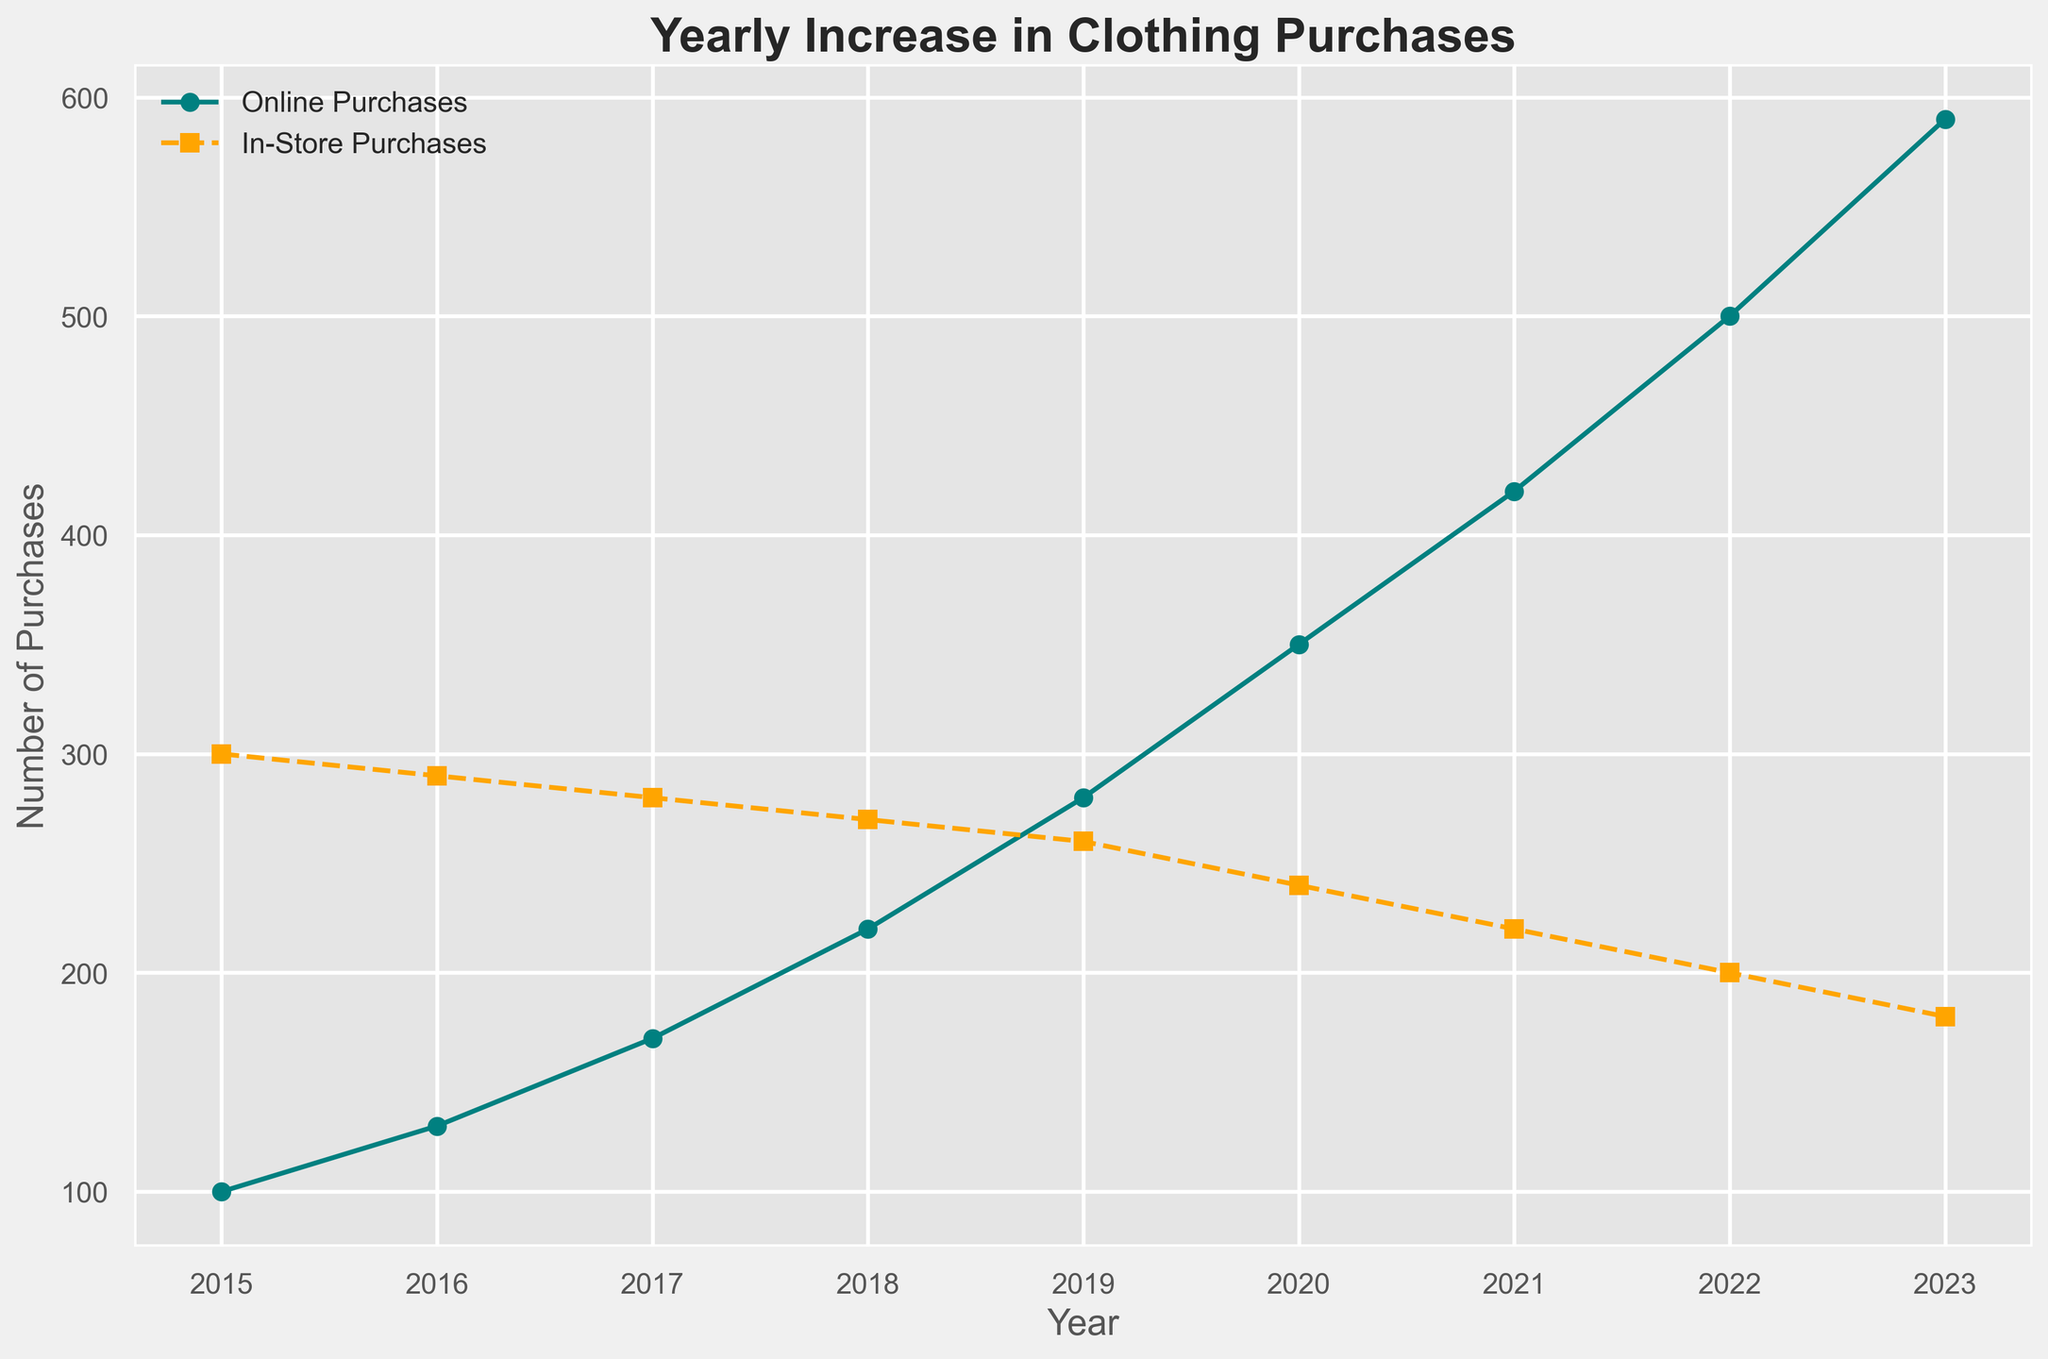What is the trend in online clothing purchases from 2015 to 2023? To determine the trend in online clothing purchases, observe the online purchases line in the chart, which shows a rising pattern year over year.
Answer: Increasing How many more online purchases were there in 2023 compared to 2015? Subtract the number of online purchases in 2015 from that in 2023: 590 - 100 = 490
Answer: 490 What is the largest difference in purchases between online and in-store in any given year? Check the vertical distance between the lines for each year. The largest difference is in 2023, with online purchases at 590 and in-store purchases at 180. Calculate the difference: 590 - 180 = 410
Answer: 410 Which year showed the smallest difference between online and in-store purchases? Look at the vertical distance between the lines for each year. The smallest difference is in 2015 where online purchases are 100 and in-store are 300. Calculate the difference: 300 - 100 = 200
Answer: 2015 In which year did online purchases surpass in-store purchases? Look at the lines to see where the online purchases line crosses above the in-store purchases line. This occurs between 2018 (220 online, 270 in-store) and 2019 (280 online, 260 in-store).
Answer: 2019 How much did in-store purchases decrease from 2015 to 2023? Subtract the number of in-store purchases in 2023 from that in 2015: 300 - 180 = 120
Answer: 120 What is the average number of online purchases from 2015 to 2023? Sum the online purchases from each year and divide by the number of years: (100 + 130 + 170 + 220 + 280 + 350 + 420 + 500 + 590) / 9 = 306.67
Answer: 306.67 Identify the year with the highest number of online purchases. Find the year with the peak of the online purchases curve, which is 2023 at 590 purchases.
Answer: 2023 Compare the trend slopes of online and in-store purchases. Which one is steeper and what does this indicate? The slope of the online purchases line is steeper than the in-store purchases line, indicating a faster increase in online purchases compared to the drop in in-store purchases over the years.
Answer: Online purchases slope is steeper From 2018 to 2022, what is the average yearly increase in online purchases? Calculate the total increase in online purchases from 2018 to 2022 (500 - 220) = 280. Then divide this by the number of years: 280 / 4 = 70
Answer: 70 